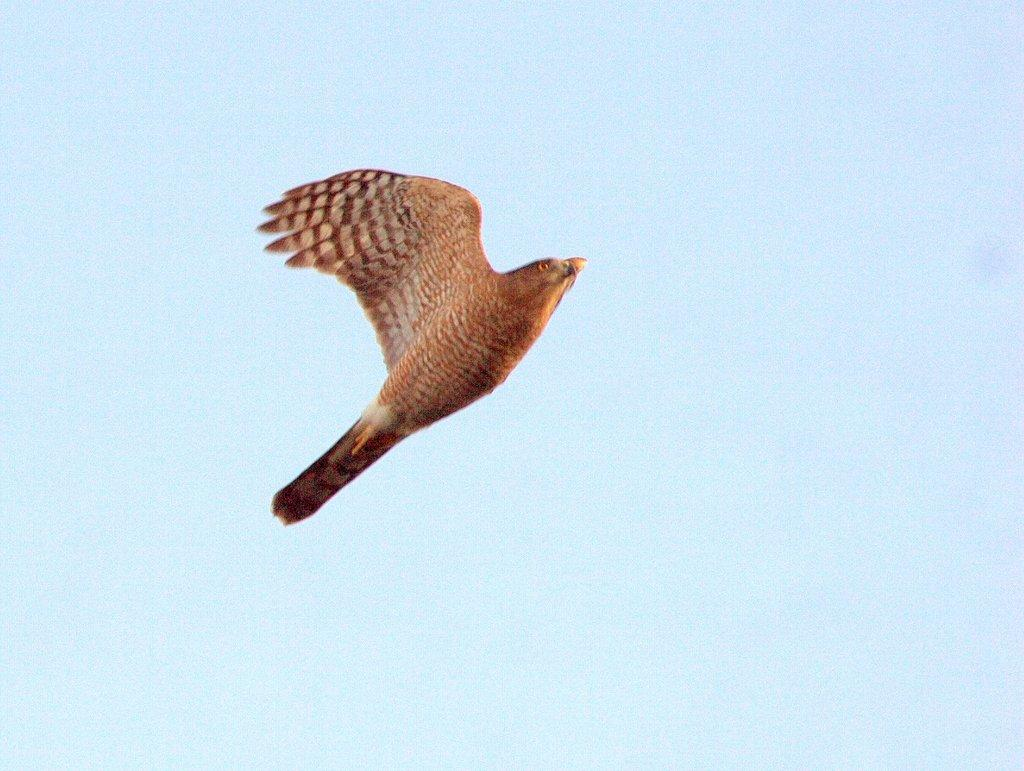What type of animal is in the image? There is a bird in the image. What color is the bird? The bird is brown in color. What can be seen in the background of the image? There is sky visible in the background of the image. What type of texture does the giraffe have in the image? There is no giraffe present in the image, so we cannot determine its texture. 